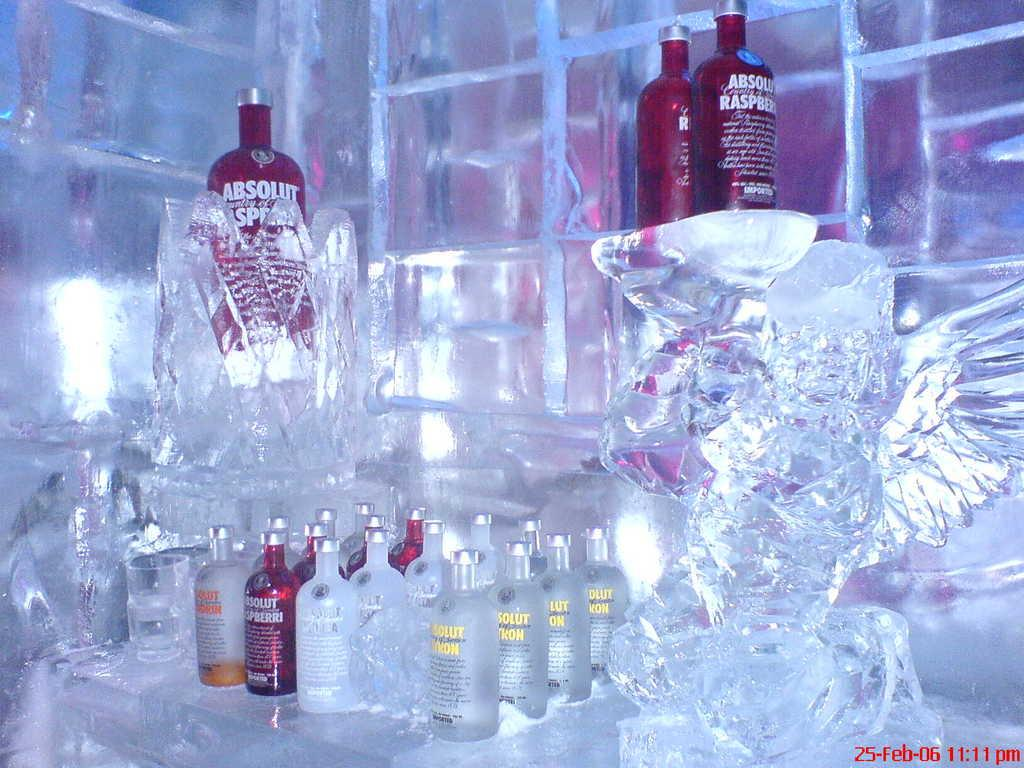Provide a one-sentence caption for the provided image. A picture of an ice sculpture and several bottles of vodka that was taken on February 25, 2006. 